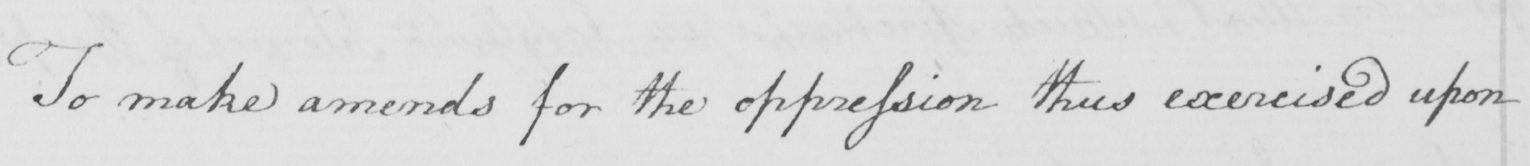Please transcribe the handwritten text in this image. To make amends for the oppression thus exercised upon 